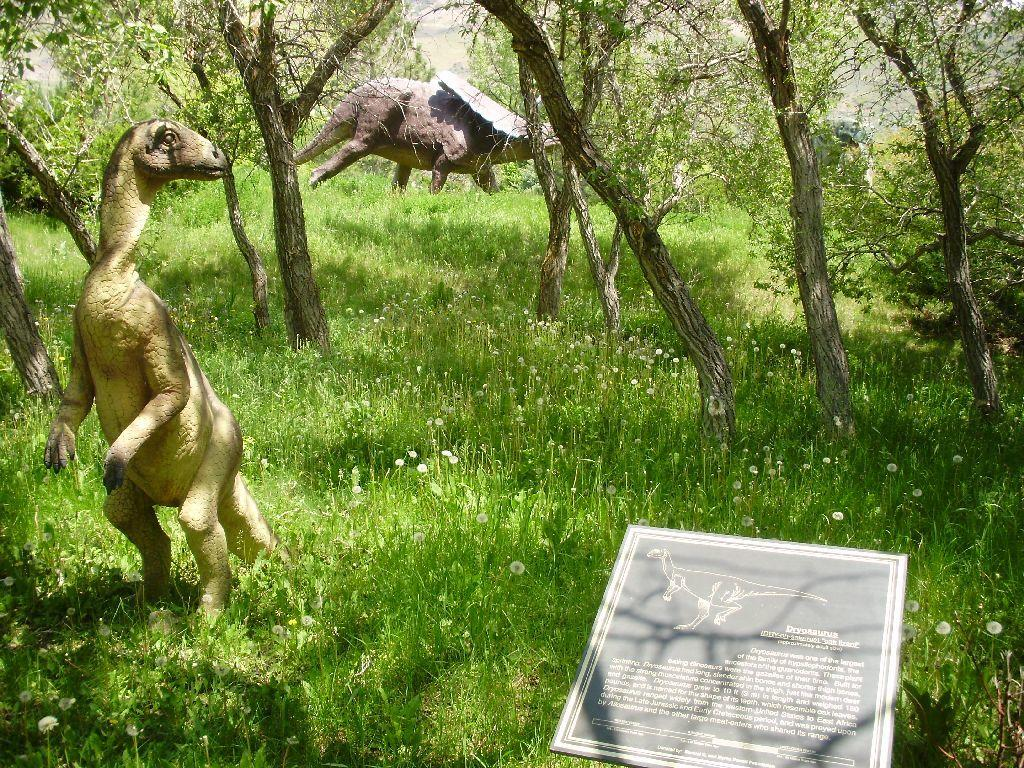What type of vegetation can be seen in the image? There is grass and trees in the image. What other notable subjects are present in the image? There are dinosaurs in the image. Is there any additional signage or decoration in the image? Yes, there is a banner in the image. What type of wool is being used to balance the dinosaurs in the image? There is no wool present in the image, nor is there any indication of the dinosaurs needing to be balanced. 